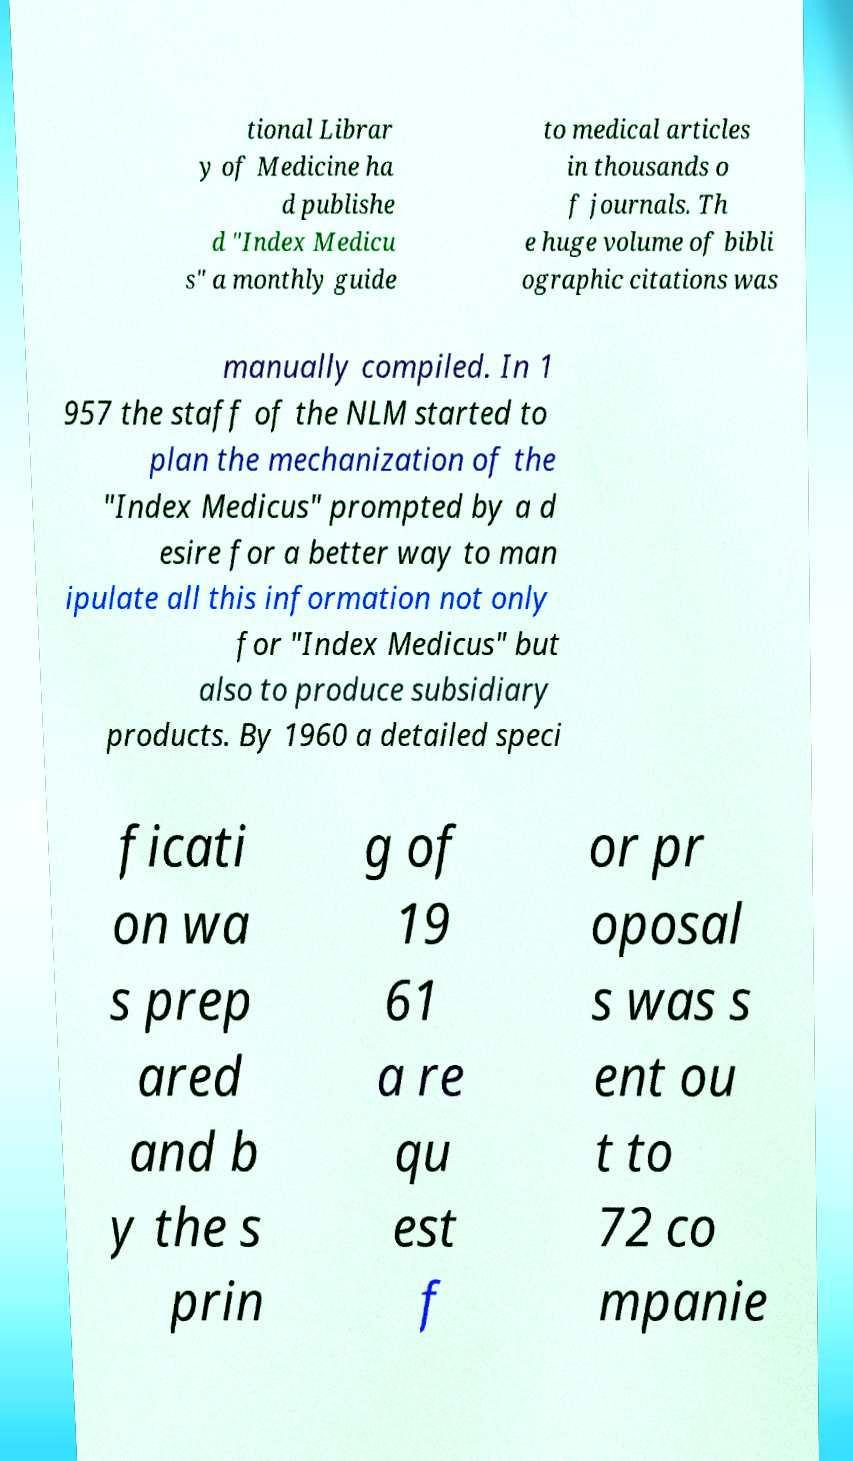Please read and relay the text visible in this image. What does it say? tional Librar y of Medicine ha d publishe d "Index Medicu s" a monthly guide to medical articles in thousands o f journals. Th e huge volume of bibli ographic citations was manually compiled. In 1 957 the staff of the NLM started to plan the mechanization of the "Index Medicus" prompted by a d esire for a better way to man ipulate all this information not only for "Index Medicus" but also to produce subsidiary products. By 1960 a detailed speci ficati on wa s prep ared and b y the s prin g of 19 61 a re qu est f or pr oposal s was s ent ou t to 72 co mpanie 